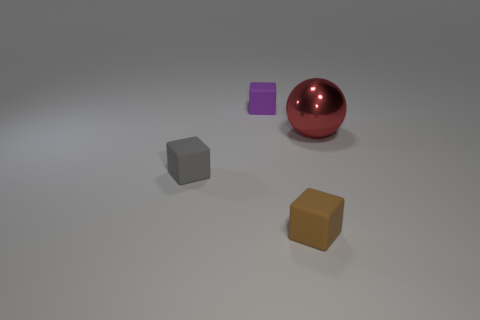Subtract 1 blocks. How many blocks are left? 2 Add 1 small purple blocks. How many objects exist? 5 Subtract all spheres. How many objects are left? 3 Subtract all small cyan rubber spheres. Subtract all small gray things. How many objects are left? 3 Add 3 matte cubes. How many matte cubes are left? 6 Add 3 red metallic objects. How many red metallic objects exist? 4 Subtract 0 brown spheres. How many objects are left? 4 